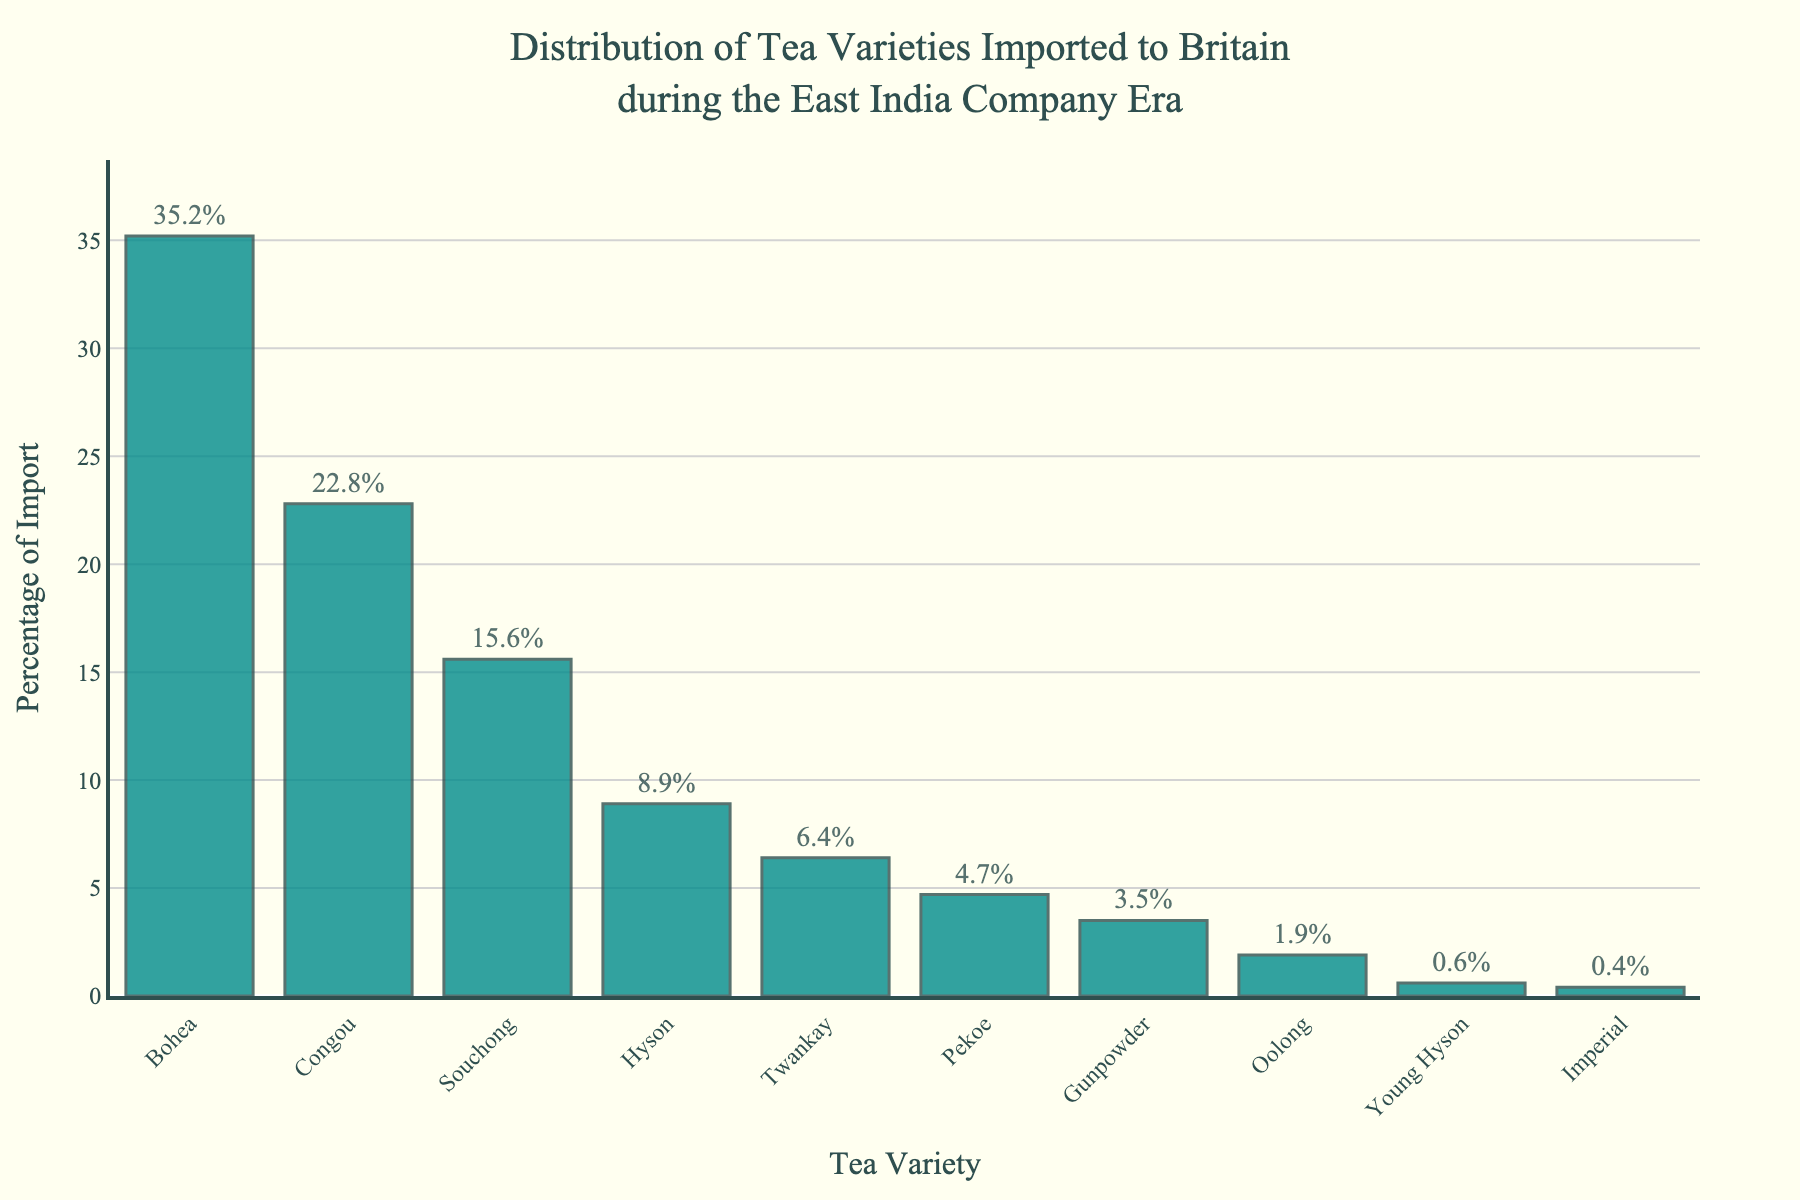What's the tea variety with the highest percentage of import? Looking at the bar chart, identify the bar with the greatest height. The tea variety corresponding to this bar is Bohea, which has the highest percentage of import.
Answer: Bohea What is the combined percentage of import for Souchong and Hyson? First, find the percentage of import for Souchong and Hyson from the chart, which are 15.6% and 8.9%, respectively. Add these two percentages together: 15.6 + 8.9 = 24.5.
Answer: 24.5% How much greater is the percentage of Bohea's import compared to Gunpowder's? Bohea's percentage of import is 35.2%, while Gunpowder's is 3.5%. Subtract Gunpowder's value from Bohea's: 35.2 - 3.5 = 31.7.
Answer: 31.7% Which tea varieties have a percentage of import greater than 20%? Identify the bars whose heights correspond to percentages above 20%. These are Bohea and Congou, with percentages of 35.2% and 22.8%, respectively.
Answer: Bohea, Congou What is the total percentage of import for the three varieties with the lowest import percentages? Find the import percentages for the three varieties with the smallest bars: Young Hyson (0.6%), Imperial (0.4%), and Oolong (1.9%). Sum these percentages: 0.6 + 0.4 + 1.9 = 2.9.
Answer: 2.9% Between which tea varieties is the difference in import percentage the smallest? Examine the differences in import percentages between successive tea varieties. The smallest difference is between Gunpowder (3.5%) and Oolong (1.9%). Calculate the difference: 3.5 - 1.9 = 1.6.
Answer: Gunpowder and Oolong If you were to represent the three largest import percentages with pie slices, what fraction of the full circle would they occupy? The three largest import percentages are Bohea (35.2%), Congou (22.8%), and Souchong (15.6%). Sum these percentages: 35.2 + 22.8 + 15.6 = 73.6. Since a full circle represents 100%, the fraction of the circle is 73.6 / 100 = 0.736 or 73.6%.
Answer: 73.6% Which tea variety has an import percentage closest to the average import percentage of all varieties? First, calculate the average import percentage. Sum all the percentages and divide by the number of varieties: (35.2 + 22.8 + 15.6 + 8.9 + 6.4 + 4.7 + 3.5 + 1.9 + 0.6 + 0.4) / 10 = 10.0. The tea variety closest to this average is Hyson with 8.9%.
Answer: Hyson What visual attribute helps you immediately identify the most and least imported tea varieties? The height of the bars visually represents the percentage of import. The tallest bar indicates the most imported variety (Bohea), while the shortest bar indicates the least imported variety (Imperial).
Answer: Height of the bars 